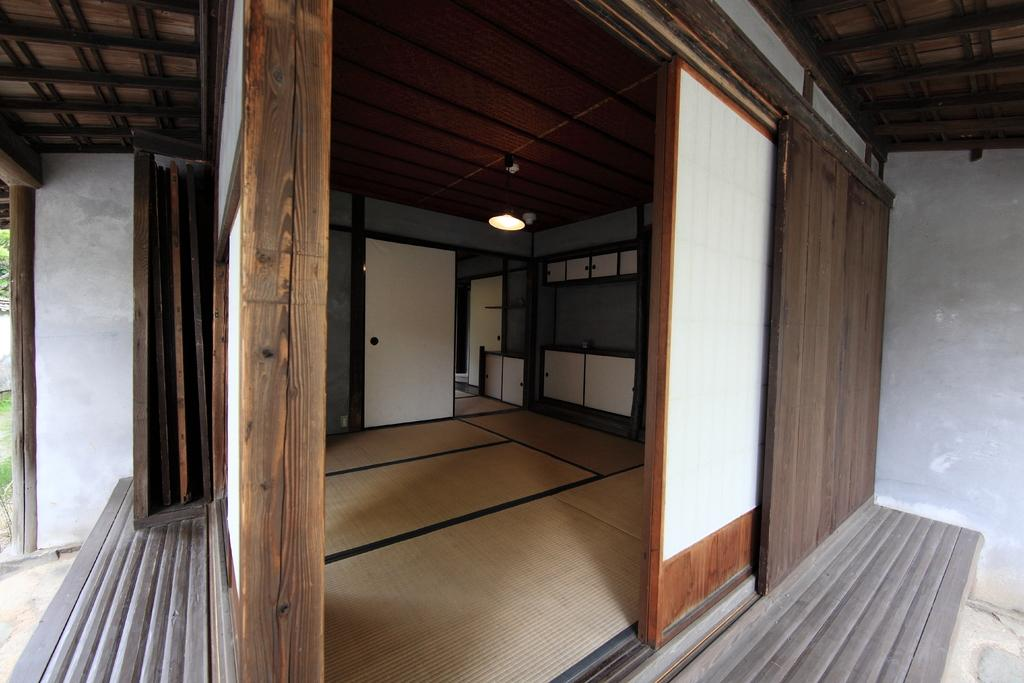Where is the setting of the image? The image is inside a house. What are some features of the house that can be seen in the image? There are doors, a cupboard, mats on the floor, walls, and a light attached to the rooftop. What type of eggs are being discussed in the meeting happening in the image? There is no meeting or discussion of eggs present in the image. 